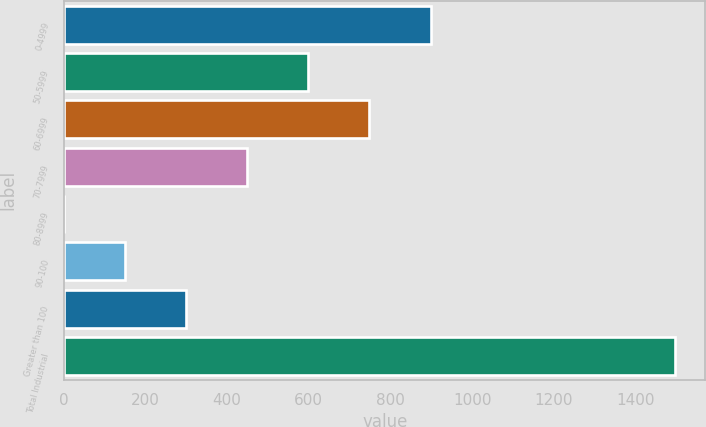Convert chart to OTSL. <chart><loc_0><loc_0><loc_500><loc_500><bar_chart><fcel>0-4999<fcel>50-5999<fcel>60-6999<fcel>70-7999<fcel>80-8999<fcel>90-100<fcel>Greater than 100<fcel>Total Industrial<nl><fcel>898.3<fcel>598.96<fcel>748.63<fcel>449.29<fcel>0.28<fcel>149.95<fcel>299.62<fcel>1497<nl></chart> 